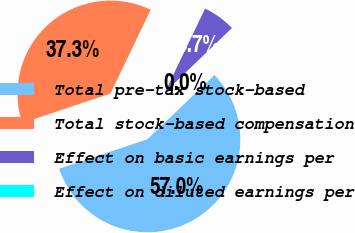<chart> <loc_0><loc_0><loc_500><loc_500><pie_chart><fcel>Total pre-tax stock-based<fcel>Total stock-based compensation<fcel>Effect on basic earnings per<fcel>Effect on diluted earnings per<nl><fcel>57.03%<fcel>37.26%<fcel>5.71%<fcel>0.01%<nl></chart> 